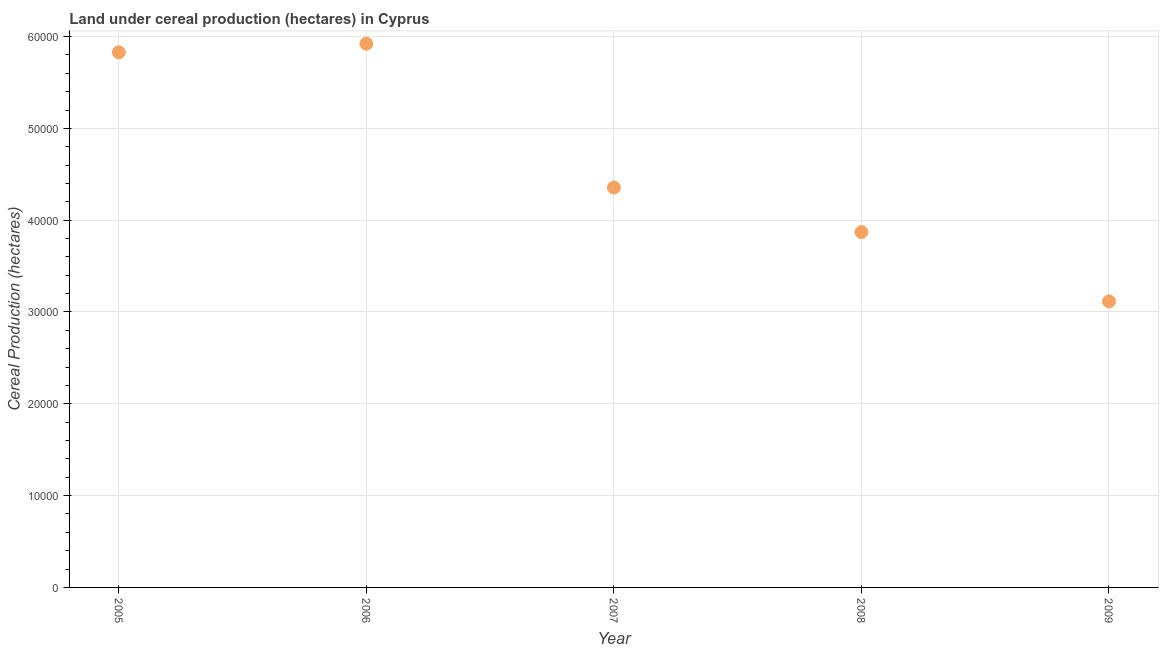What is the land under cereal production in 2007?
Provide a succinct answer. 4.36e+04. Across all years, what is the maximum land under cereal production?
Your response must be concise. 5.92e+04. Across all years, what is the minimum land under cereal production?
Give a very brief answer. 3.12e+04. In which year was the land under cereal production minimum?
Offer a terse response. 2009. What is the sum of the land under cereal production?
Ensure brevity in your answer.  2.31e+05. What is the difference between the land under cereal production in 2006 and 2009?
Offer a very short reply. 2.81e+04. What is the average land under cereal production per year?
Provide a succinct answer. 4.62e+04. What is the median land under cereal production?
Make the answer very short. 4.36e+04. Do a majority of the years between 2009 and 2007 (inclusive) have land under cereal production greater than 58000 hectares?
Provide a short and direct response. No. What is the ratio of the land under cereal production in 2005 to that in 2006?
Provide a succinct answer. 0.98. Is the land under cereal production in 2006 less than that in 2009?
Your answer should be very brief. No. What is the difference between the highest and the second highest land under cereal production?
Provide a succinct answer. 936. Is the sum of the land under cereal production in 2005 and 2006 greater than the maximum land under cereal production across all years?
Keep it short and to the point. Yes. What is the difference between the highest and the lowest land under cereal production?
Ensure brevity in your answer.  2.81e+04. Does the land under cereal production monotonically increase over the years?
Your answer should be very brief. No. How many years are there in the graph?
Ensure brevity in your answer.  5. Does the graph contain grids?
Your answer should be compact. Yes. What is the title of the graph?
Make the answer very short. Land under cereal production (hectares) in Cyprus. What is the label or title of the X-axis?
Keep it short and to the point. Year. What is the label or title of the Y-axis?
Give a very brief answer. Cereal Production (hectares). What is the Cereal Production (hectares) in 2005?
Your response must be concise. 5.83e+04. What is the Cereal Production (hectares) in 2006?
Keep it short and to the point. 5.92e+04. What is the Cereal Production (hectares) in 2007?
Your answer should be very brief. 4.36e+04. What is the Cereal Production (hectares) in 2008?
Your response must be concise. 3.87e+04. What is the Cereal Production (hectares) in 2009?
Provide a succinct answer. 3.12e+04. What is the difference between the Cereal Production (hectares) in 2005 and 2006?
Offer a very short reply. -936. What is the difference between the Cereal Production (hectares) in 2005 and 2007?
Keep it short and to the point. 1.47e+04. What is the difference between the Cereal Production (hectares) in 2005 and 2008?
Make the answer very short. 1.96e+04. What is the difference between the Cereal Production (hectares) in 2005 and 2009?
Offer a very short reply. 2.71e+04. What is the difference between the Cereal Production (hectares) in 2006 and 2007?
Your answer should be compact. 1.57e+04. What is the difference between the Cereal Production (hectares) in 2006 and 2008?
Your response must be concise. 2.05e+04. What is the difference between the Cereal Production (hectares) in 2006 and 2009?
Offer a terse response. 2.81e+04. What is the difference between the Cereal Production (hectares) in 2007 and 2008?
Provide a succinct answer. 4852. What is the difference between the Cereal Production (hectares) in 2007 and 2009?
Your answer should be very brief. 1.24e+04. What is the difference between the Cereal Production (hectares) in 2008 and 2009?
Give a very brief answer. 7549. What is the ratio of the Cereal Production (hectares) in 2005 to that in 2006?
Your response must be concise. 0.98. What is the ratio of the Cereal Production (hectares) in 2005 to that in 2007?
Your response must be concise. 1.34. What is the ratio of the Cereal Production (hectares) in 2005 to that in 2008?
Provide a succinct answer. 1.51. What is the ratio of the Cereal Production (hectares) in 2005 to that in 2009?
Your response must be concise. 1.87. What is the ratio of the Cereal Production (hectares) in 2006 to that in 2007?
Your answer should be compact. 1.36. What is the ratio of the Cereal Production (hectares) in 2006 to that in 2008?
Offer a very short reply. 1.53. What is the ratio of the Cereal Production (hectares) in 2006 to that in 2009?
Your answer should be very brief. 1.9. What is the ratio of the Cereal Production (hectares) in 2007 to that in 2008?
Make the answer very short. 1.12. What is the ratio of the Cereal Production (hectares) in 2007 to that in 2009?
Offer a very short reply. 1.4. What is the ratio of the Cereal Production (hectares) in 2008 to that in 2009?
Your answer should be compact. 1.24. 